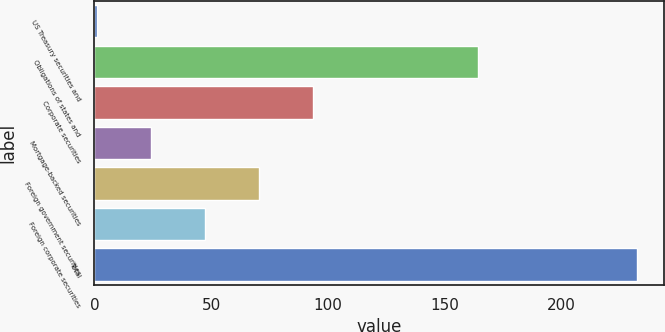Convert chart to OTSL. <chart><loc_0><loc_0><loc_500><loc_500><bar_chart><fcel>US Treasury securities and<fcel>Obligations of states and<fcel>Corporate securities<fcel>Mortgage-backed securities<fcel>Foreign government securities<fcel>Foreign corporate securities<fcel>Total<nl><fcel>1.3<fcel>164.4<fcel>93.74<fcel>24.41<fcel>70.63<fcel>47.52<fcel>232.4<nl></chart> 